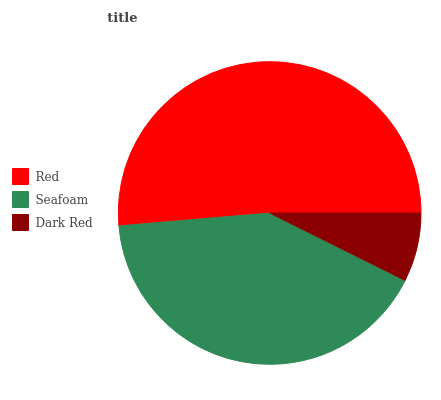Is Dark Red the minimum?
Answer yes or no. Yes. Is Red the maximum?
Answer yes or no. Yes. Is Seafoam the minimum?
Answer yes or no. No. Is Seafoam the maximum?
Answer yes or no. No. Is Red greater than Seafoam?
Answer yes or no. Yes. Is Seafoam less than Red?
Answer yes or no. Yes. Is Seafoam greater than Red?
Answer yes or no. No. Is Red less than Seafoam?
Answer yes or no. No. Is Seafoam the high median?
Answer yes or no. Yes. Is Seafoam the low median?
Answer yes or no. Yes. Is Dark Red the high median?
Answer yes or no. No. Is Red the low median?
Answer yes or no. No. 